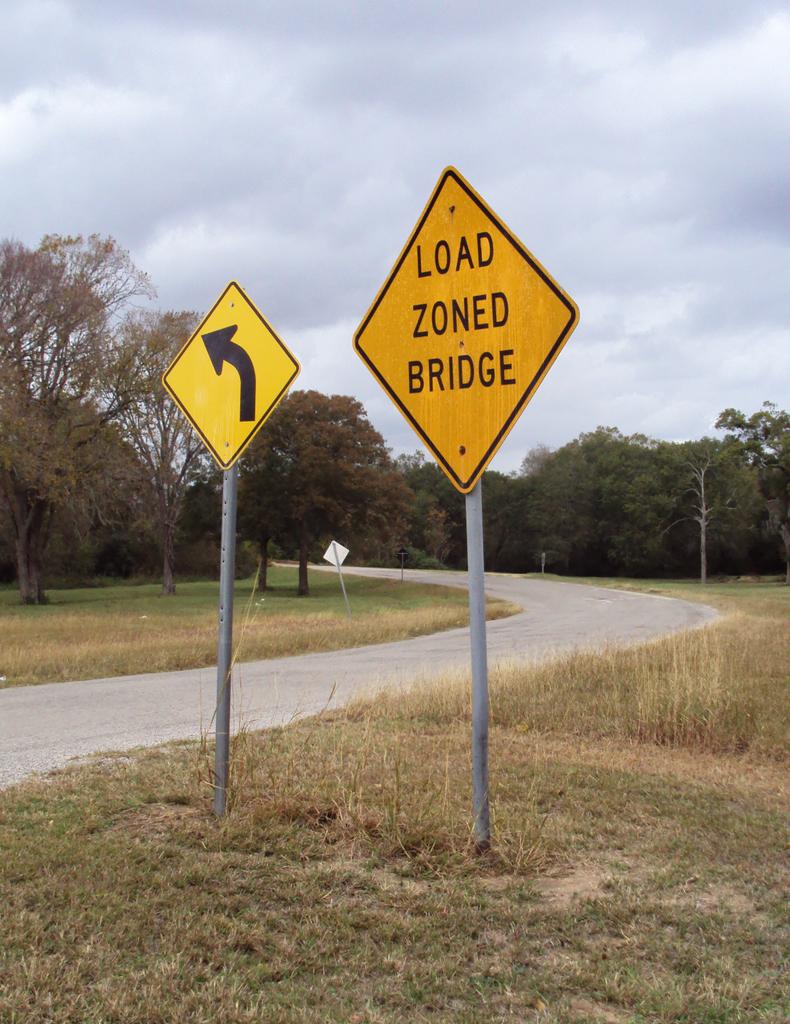Is the turn left or right?
Your answer should be compact. Left. What does the sign without the arrow say?
Provide a short and direct response. Load zoned bridge. 